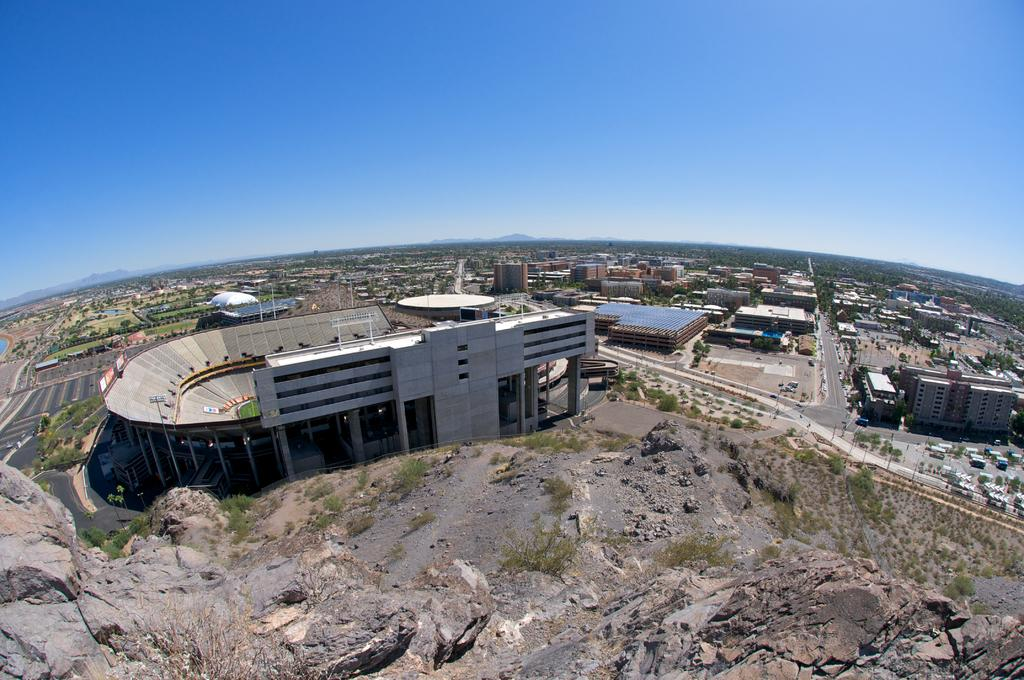What type of structure can be seen in the image? There is a building in the image. What natural elements are present in the image? There are trees and grass in the image. What geographical feature is visible in the image? There is a mountain in the image. What can be seen in the background of the image? There are other buildings, roads, more trees, and more mountains in the background of the image. What is visible in the sky in the image? The sky is visible in the background of the image. Can you tell me how many cans are present in the image? There are no cans present in the image. What type of question is being asked in the image? There is no question being asked in the image; it is a visual representation of a scene. 